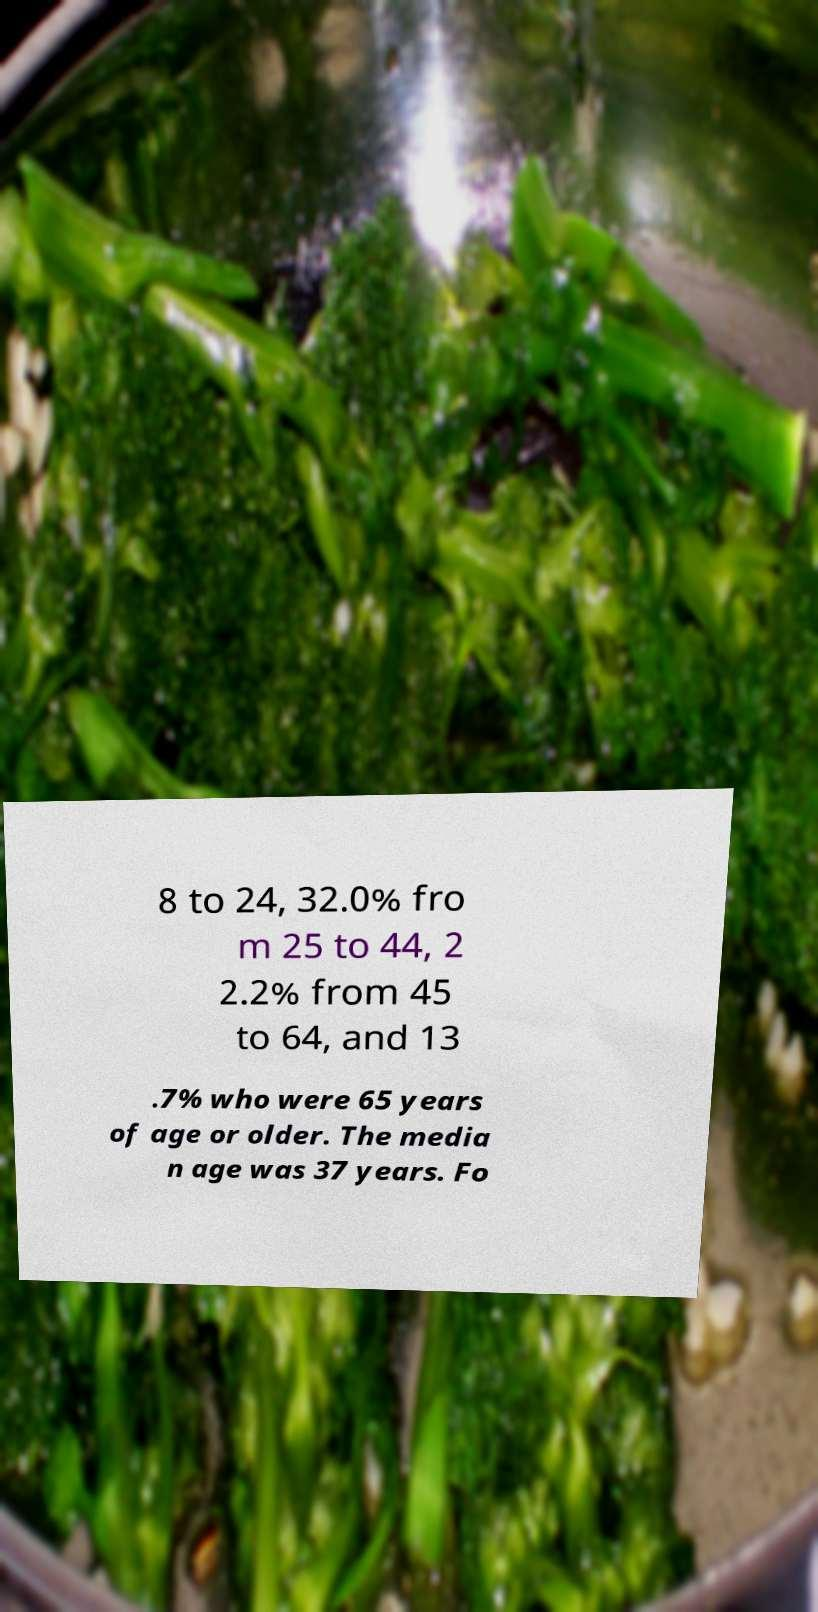I need the written content from this picture converted into text. Can you do that? 8 to 24, 32.0% fro m 25 to 44, 2 2.2% from 45 to 64, and 13 .7% who were 65 years of age or older. The media n age was 37 years. Fo 